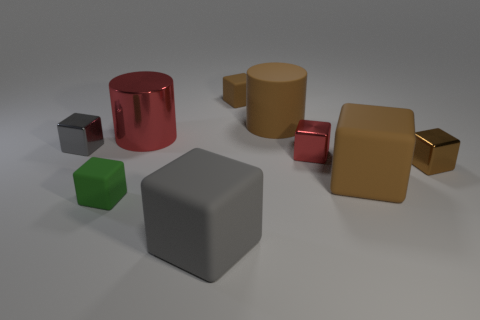How many other things are the same color as the big metallic object? There appears to be one small object that shares a similar color with the large metallic cube—it is the smaller cube located to the left of the larger one. 